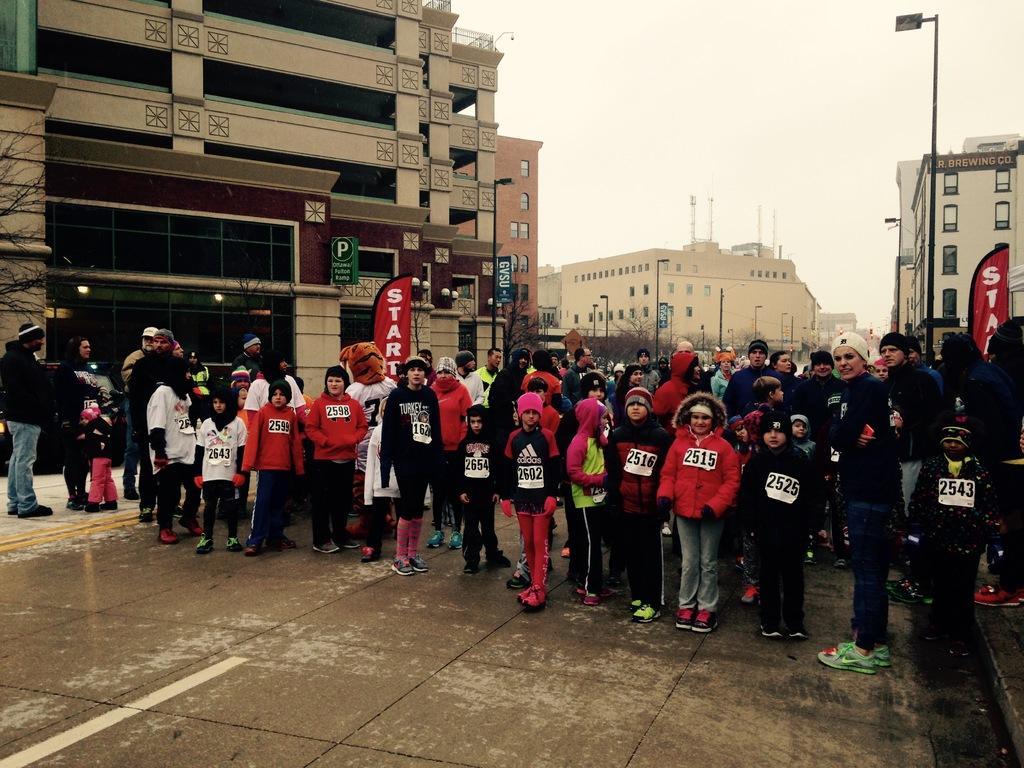What is happening in the foreground of the image? There is a group of people standing on the road in the foreground of the image. What can be seen in the background of the image? There are buildings, light poles, and trees visible in the background of the image. What is the condition of the sky in the image? There are clouds in the sky in the image. What type of unit is being measured by the clouds in the image? The clouds in the image are not measuring any unit; they are simply visible in the sky. What is the front of the image showing? The front of the image is showing a group of people standing on the road, as mentioned in the first fact. 